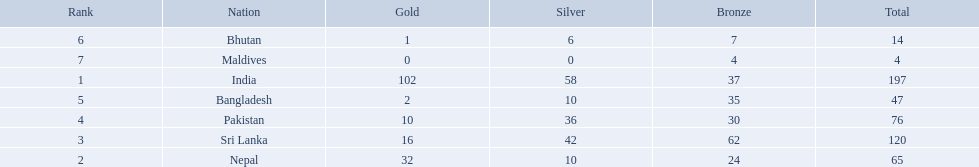What were the total amount won of medals by nations in the 1999 south asian games? 197, 65, 120, 76, 47, 14, 4. Which amount was the lowest? 4. Which nation had this amount? Maldives. 